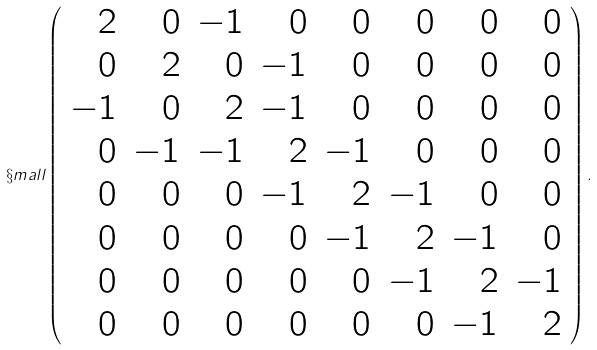Convert formula to latex. <formula><loc_0><loc_0><loc_500><loc_500>\S m a l l { \left ( \begin{array} { r r r r r r r r } 2 & 0 & - 1 & 0 & 0 & 0 & 0 & 0 \\ 0 & 2 & 0 & - 1 & 0 & 0 & 0 & 0 \\ - 1 & 0 & 2 & - 1 & 0 & 0 & 0 & 0 \\ 0 & - 1 & - 1 & 2 & - 1 & 0 & 0 & 0 \\ 0 & 0 & 0 & - 1 & 2 & - 1 & 0 & 0 \\ 0 & 0 & 0 & 0 & - 1 & 2 & - 1 & 0 \\ 0 & 0 & 0 & 0 & 0 & - 1 & 2 & - 1 \\ 0 & 0 & 0 & 0 & 0 & 0 & - 1 & 2 \\ \end{array} \right ) . }</formula> 